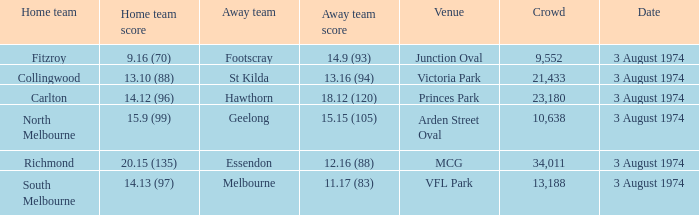Which Home team has a Venue of arden street oval? North Melbourne. 